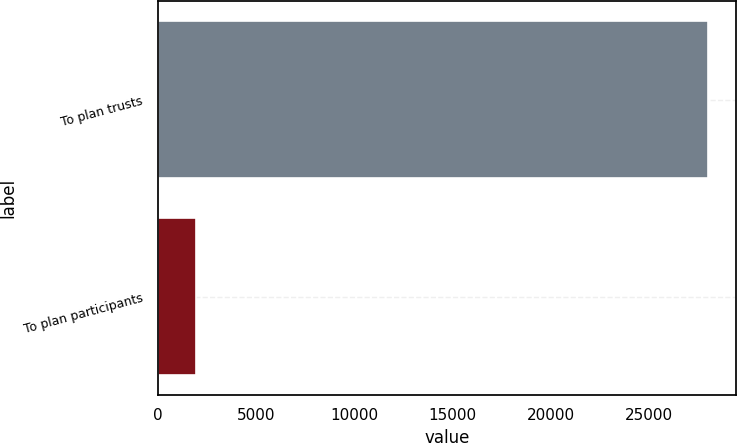Convert chart to OTSL. <chart><loc_0><loc_0><loc_500><loc_500><bar_chart><fcel>To plan trusts<fcel>To plan participants<nl><fcel>28000<fcel>1929<nl></chart> 